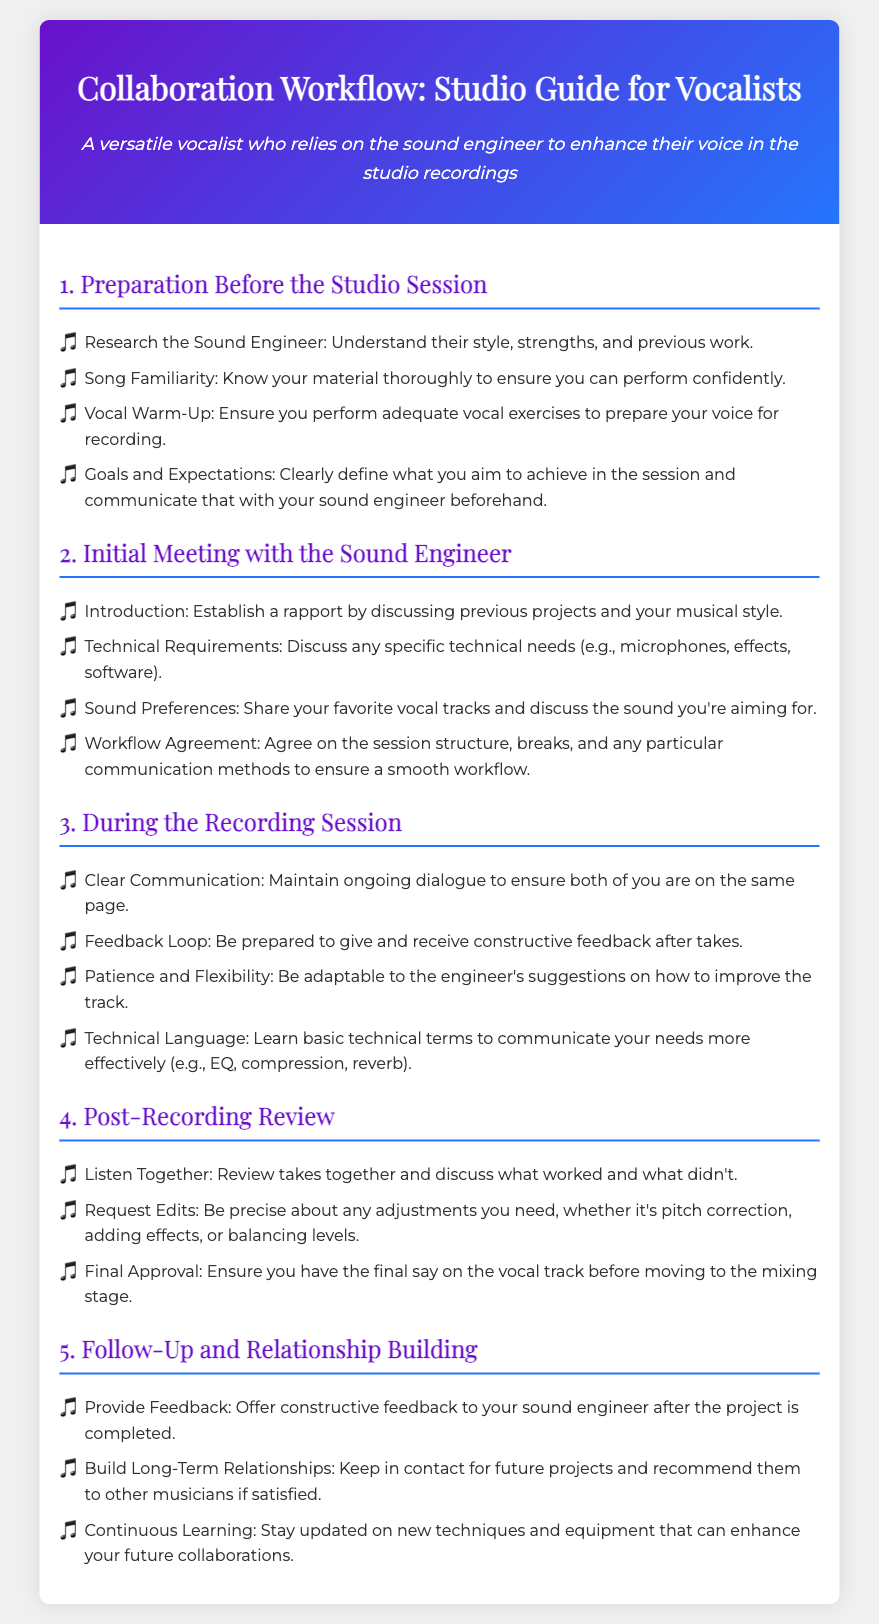What is the first step in the collaboration workflow? The first step in the collaboration workflow is "Preparation Before the Studio Session," as indicated in the document's sections.
Answer: Preparation Before the Studio Session What should vocalists define before the studio session? Vocalists should clearly define their goals and expectations for the session, according to the document.
Answer: Goals and Expectations What is one way to establish rapport with the sound engineer? One way to establish rapport is to discuss previous projects and your musical style during the initial meeting.
Answer: Discuss previous projects What is important to maintain during the recording session? Clear communication is important to ensure both the vocalist and the sound engineer are on the same page during the session.
Answer: Clear Communication What should you do after reviewing takes together? After reviewing takes together, you should request any necessary edits as per the document's recommendations.
Answer: Request Edits In which section is the feedback loop mentioned? The feedback loop is mentioned in the section titled "During the Recording Session."
Answer: During the Recording Session How can vocalists build long-term relationships with sound engineers? Vocalists can build long-term relationships by keeping in contact for future projects and recommending them to others if satisfied.
Answer: Keep in contact What type of feedback should vocalists provide after a project? Vocalists should provide constructive feedback to their sound engineer after the project is completed.
Answer: Constructive feedback 